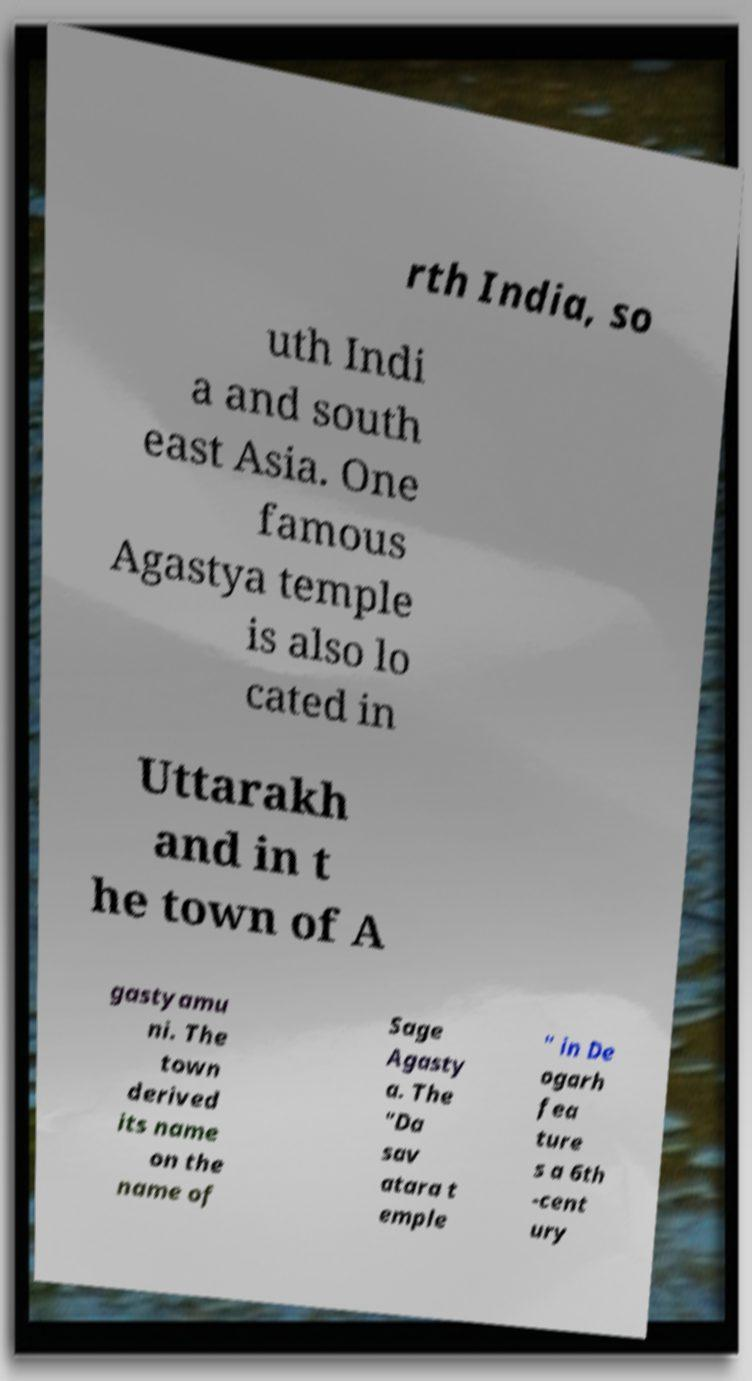There's text embedded in this image that I need extracted. Can you transcribe it verbatim? rth India, so uth Indi a and south east Asia. One famous Agastya temple is also lo cated in Uttarakh and in t he town of A gastyamu ni. The town derived its name on the name of Sage Agasty a. The "Da sav atara t emple " in De ogarh fea ture s a 6th -cent ury 